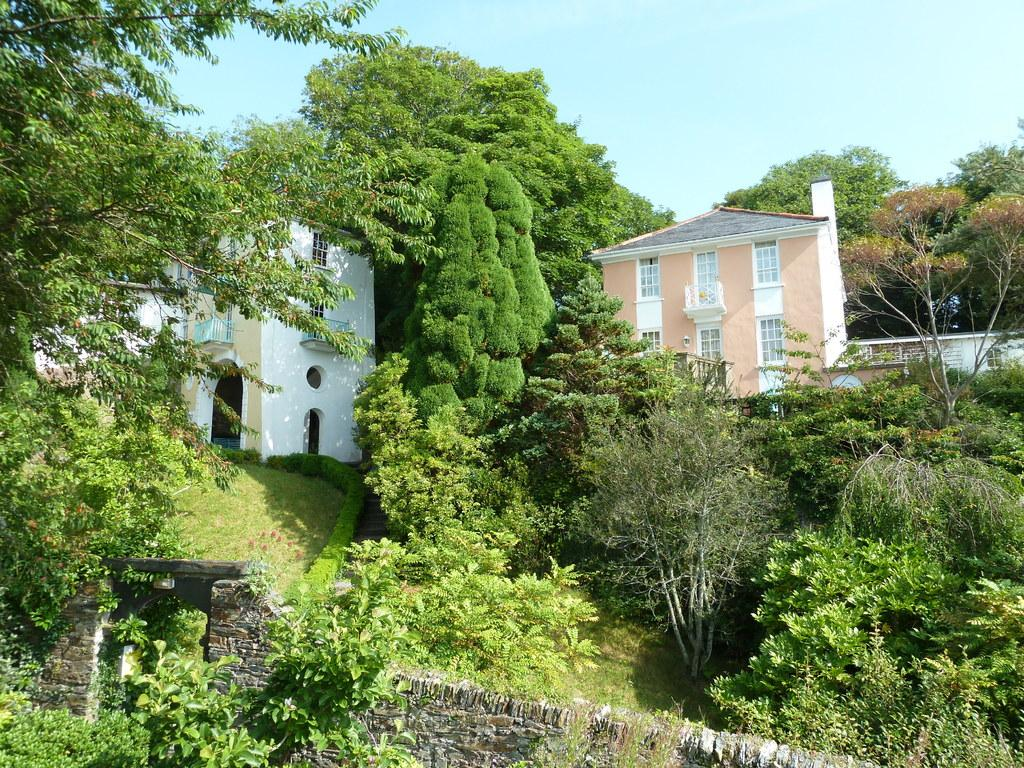What type of vegetation is present in the image? There is a group of trees and plants in the image. What is the surface on which the trees and plants are growing? There is grass in the image. What structure can be seen in the image? There is a wall in the image. What can be seen behind the trees in the image? Buildings are visible behind the trees. What is visible at the top of the image? The sky is visible at the top of the image. Can you see a boat in the image? There is no boat present in the image. 